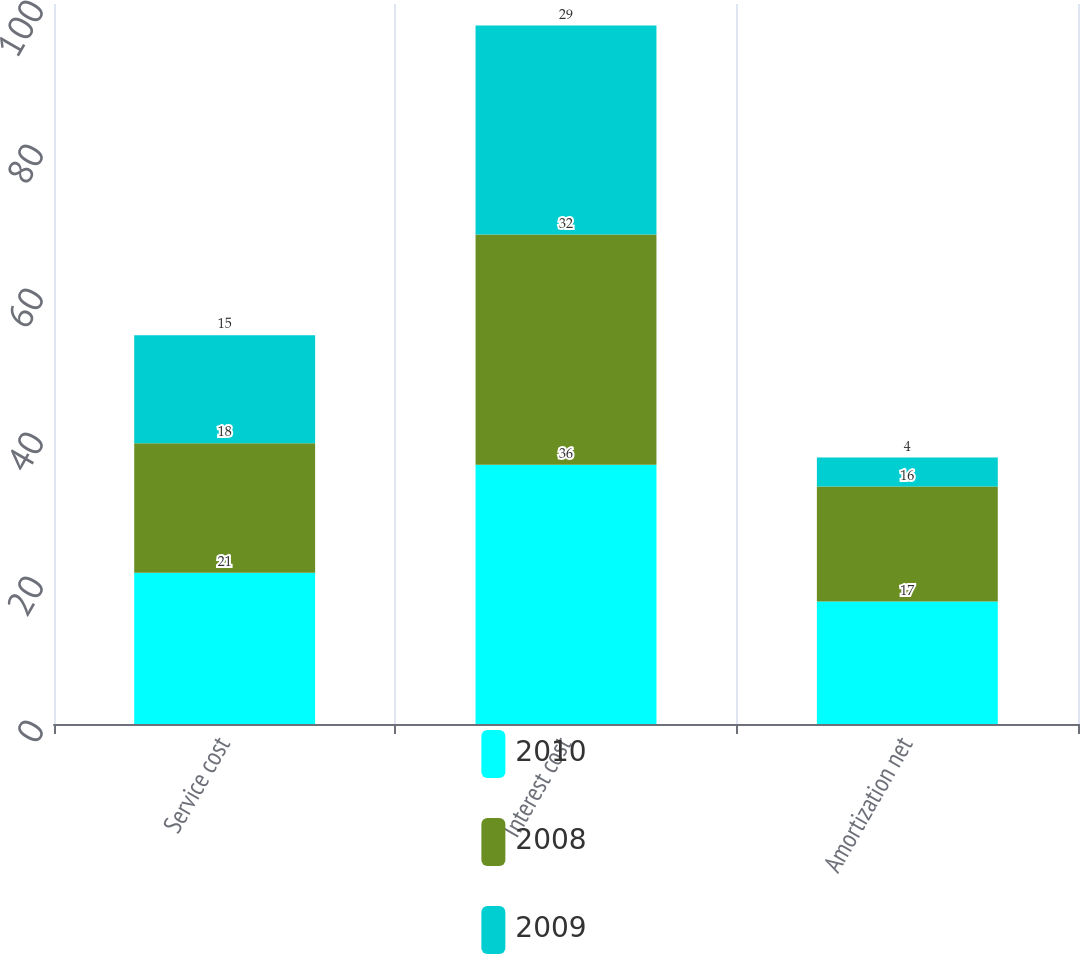Convert chart. <chart><loc_0><loc_0><loc_500><loc_500><stacked_bar_chart><ecel><fcel>Service cost<fcel>Interest cost<fcel>Amortization net<nl><fcel>2010<fcel>21<fcel>36<fcel>17<nl><fcel>2008<fcel>18<fcel>32<fcel>16<nl><fcel>2009<fcel>15<fcel>29<fcel>4<nl></chart> 